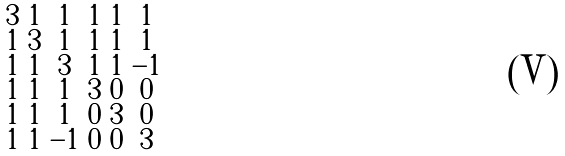<formula> <loc_0><loc_0><loc_500><loc_500>\begin{smallmatrix} 3 & 1 & 1 & 1 & 1 & 1 \\ 1 & 3 & 1 & 1 & 1 & 1 \\ 1 & 1 & 3 & 1 & 1 & - 1 \\ 1 & 1 & 1 & 3 & 0 & 0 \\ 1 & 1 & 1 & 0 & 3 & 0 \\ 1 & 1 & - 1 & 0 & 0 & 3 \end{smallmatrix}</formula> 